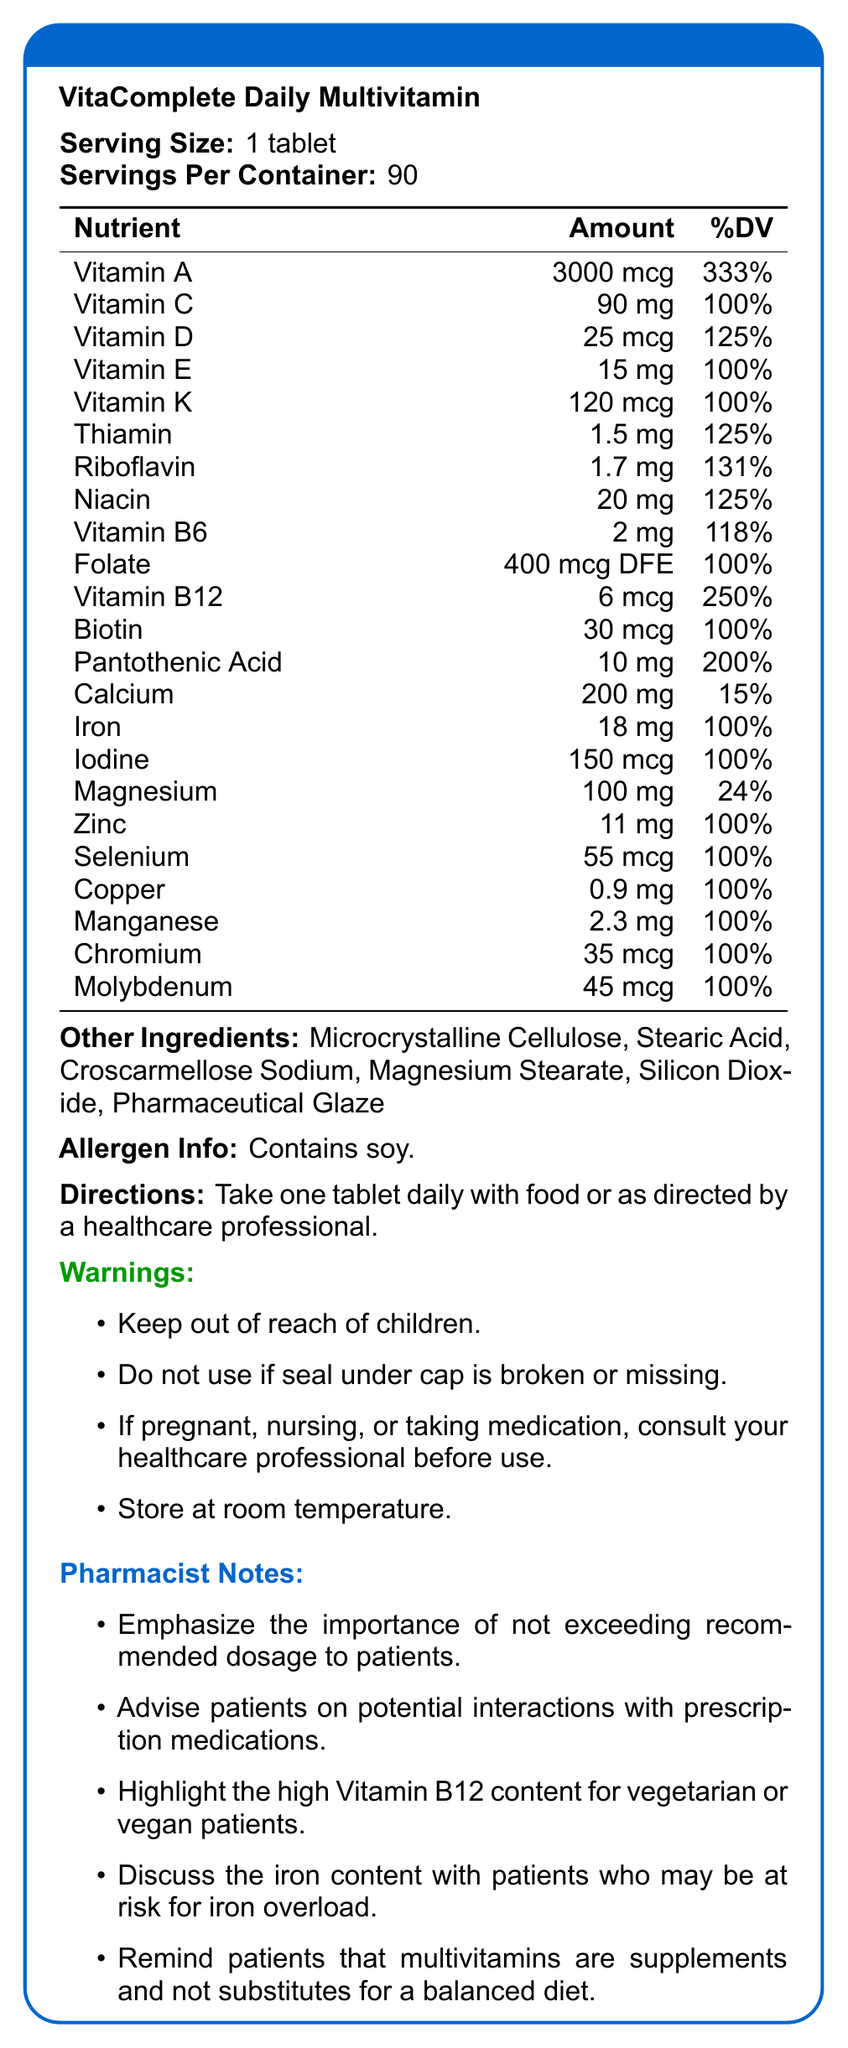what is the serving size for VitaComplete Daily Multivitamin? The document clearly states that the serving size is 1 tablet.
Answer: 1 tablet how many nutrients have a daily value of 100%? There are 12 nutrients listed with a daily value (DV) of 100%: Vitamin C, Vitamin E, Vitamin K, Folate, Biotin, Iron, Iodine, Zinc, Selenium, Copper, Manganese, and Molybdenum.
Answer: 12 what should patients do if they are pregnant, nursing, or taking medication? The warnings section advises patients who are pregnant, nursing, or taking medication to consult their healthcare professional before use.
Answer: Consult their healthcare professional before use which vitamin has the highest daily value percentage? Vitamin A has the highest daily value percentage at 333%.
Answer: Vitamin A what is the calcium content in percentage of daily value? The calcium content in the multivitamin is 200 mg, which corresponds to 15% of the daily value.
Answer: 15% which of the following vitamins has a daily value percentage of 125%? A. Vitamin D B. Vitamin C C. Vitamin B6 The daily value of Vitamin D is 125%, whereas Vitamin C and Vitamin B6 have different percentages.
Answer: A. Vitamin D which ingredient is not listed under "Other Ingredients"? A. Microcrystalline Cellulose B. Ascorbic Acid C. Stearic Acid Ascorbic Acid is not listed under "Other Ingredients". The other ingredients listed are Microcrystalline Cellulose and Stearic Acid.
Answer: B. Ascorbic Acid does this multivitamin contain any allergens? The document notes that this multivitamin contains soy, which is an allergen.
Answer: Yes is the daily value percentage for Vitamin B12 higher than that for Vitamin K? Vitamin B12 has a daily value percentage of 250%, which is higher than the 100% daily value percentage for Vitamin K.
Answer: Yes please summarize the main idea of this document. This summary captures the overall content of the document, outlining the key sections and information provided in the Nutrition Facts Label.
Answer: The document is a Nutrition Facts Label for VitaComplete Daily Multivitamin, detailing the serving size, nutrients with their amounts and daily value percentages, other ingredients, allergen information, directions for use, warnings, and pharmacist notes. what is the manufacturing date of this multivitamin? The document does not provide any details about the manufacturing date of the multivitamin.
Answer: Not enough information 